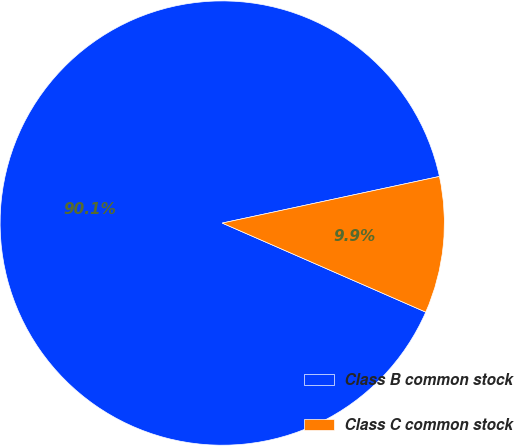Convert chart. <chart><loc_0><loc_0><loc_500><loc_500><pie_chart><fcel>Class B common stock<fcel>Class C common stock<nl><fcel>90.07%<fcel>9.93%<nl></chart> 